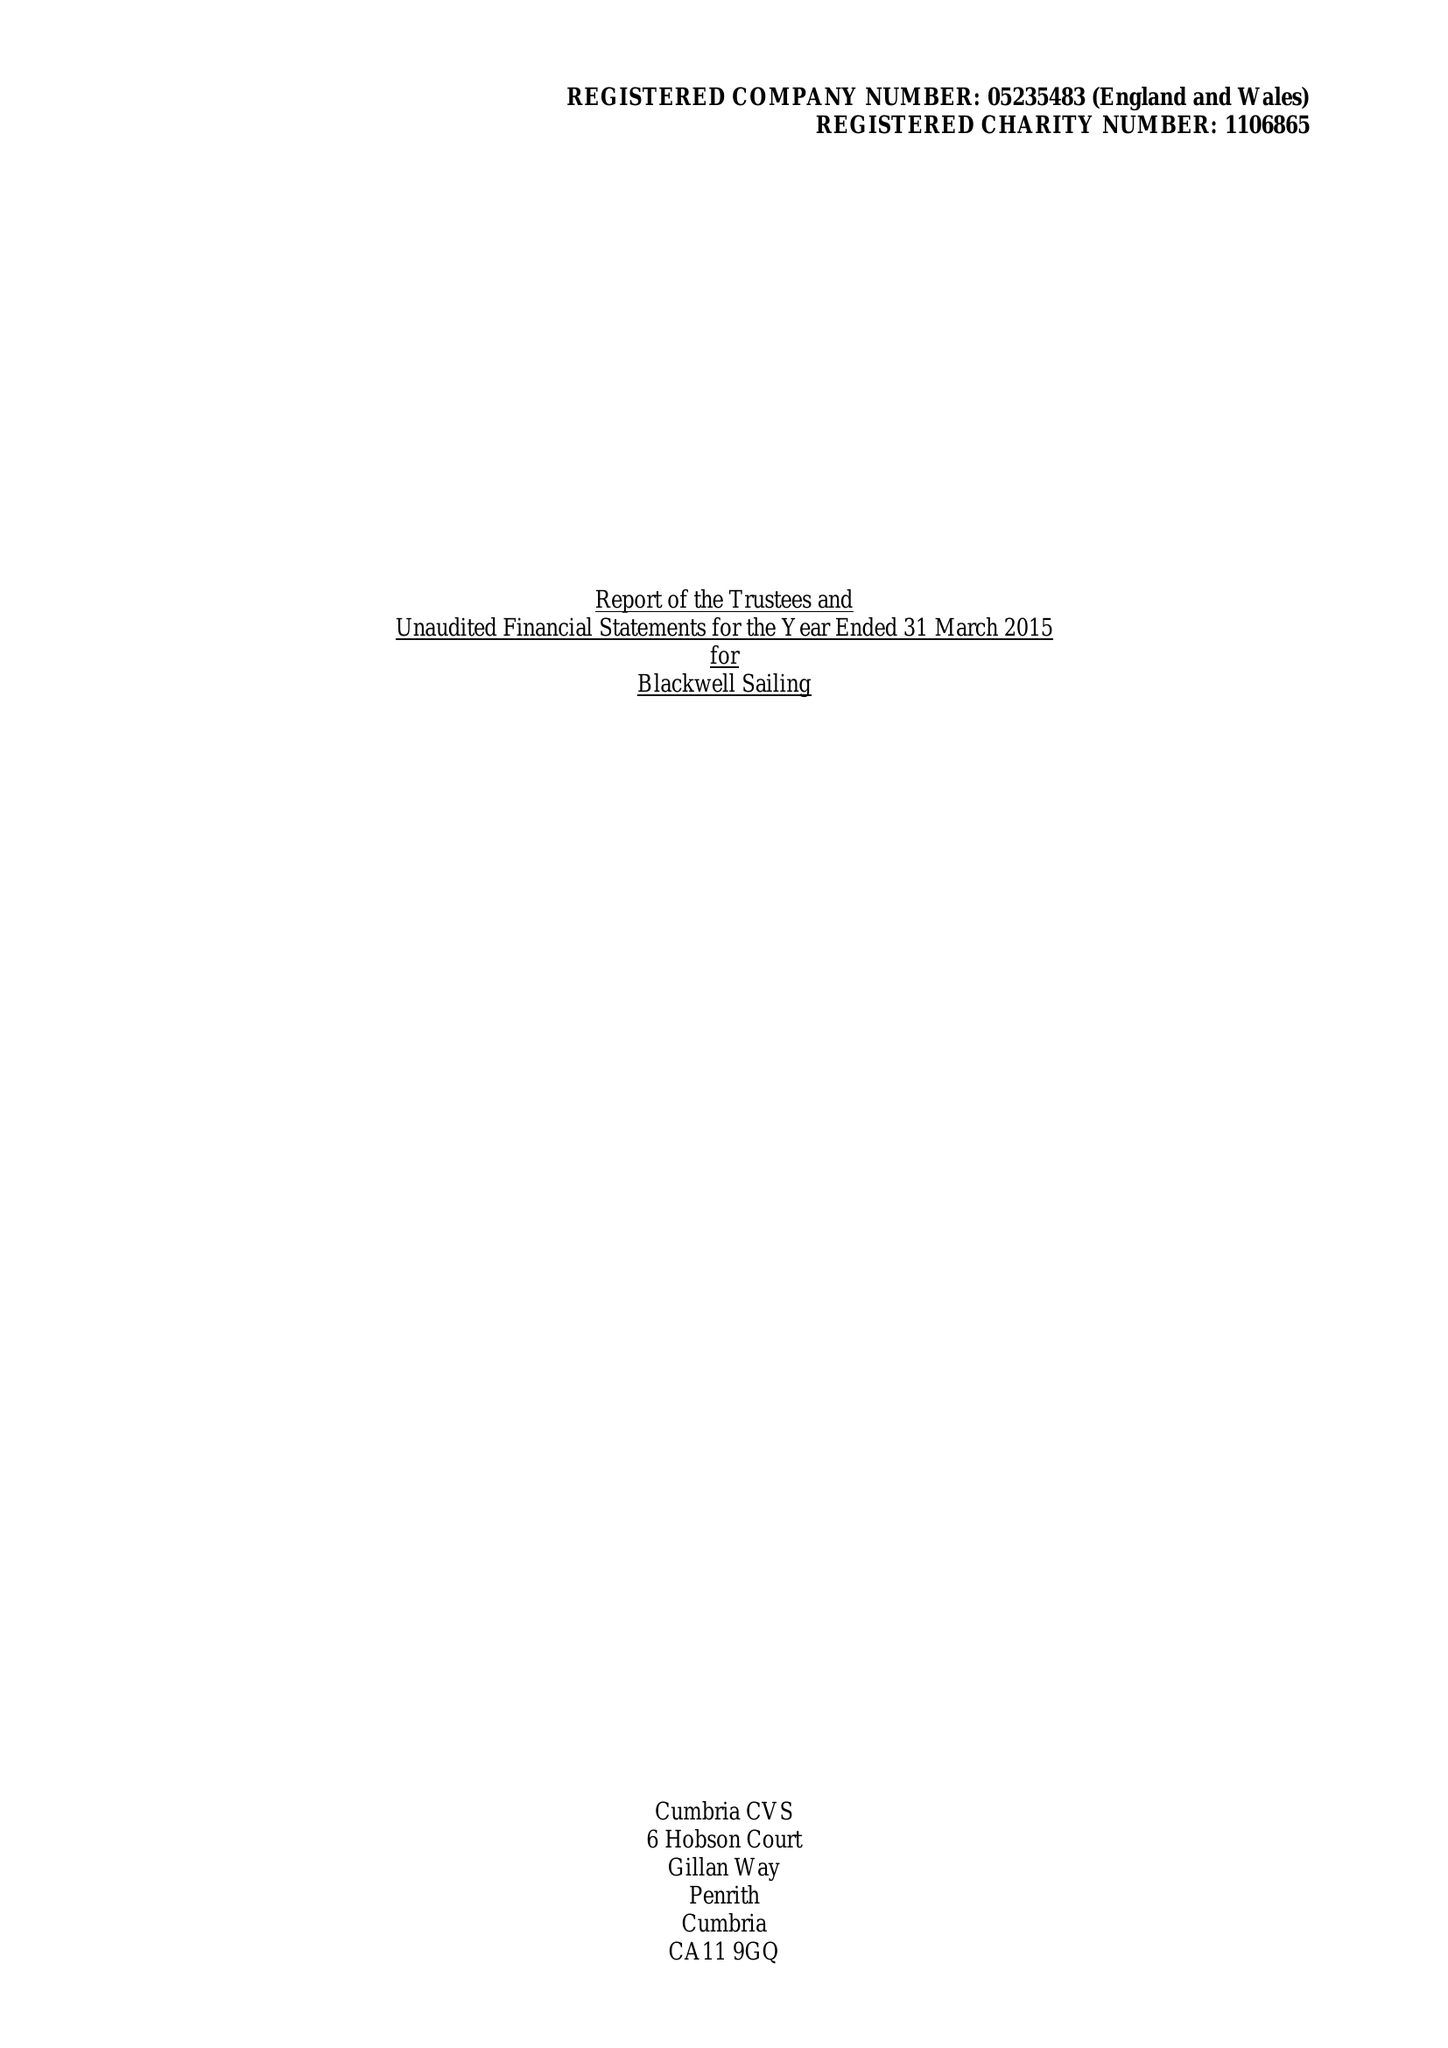What is the value for the charity_name?
Answer the question using a single word or phrase. Blackwell Sailing 